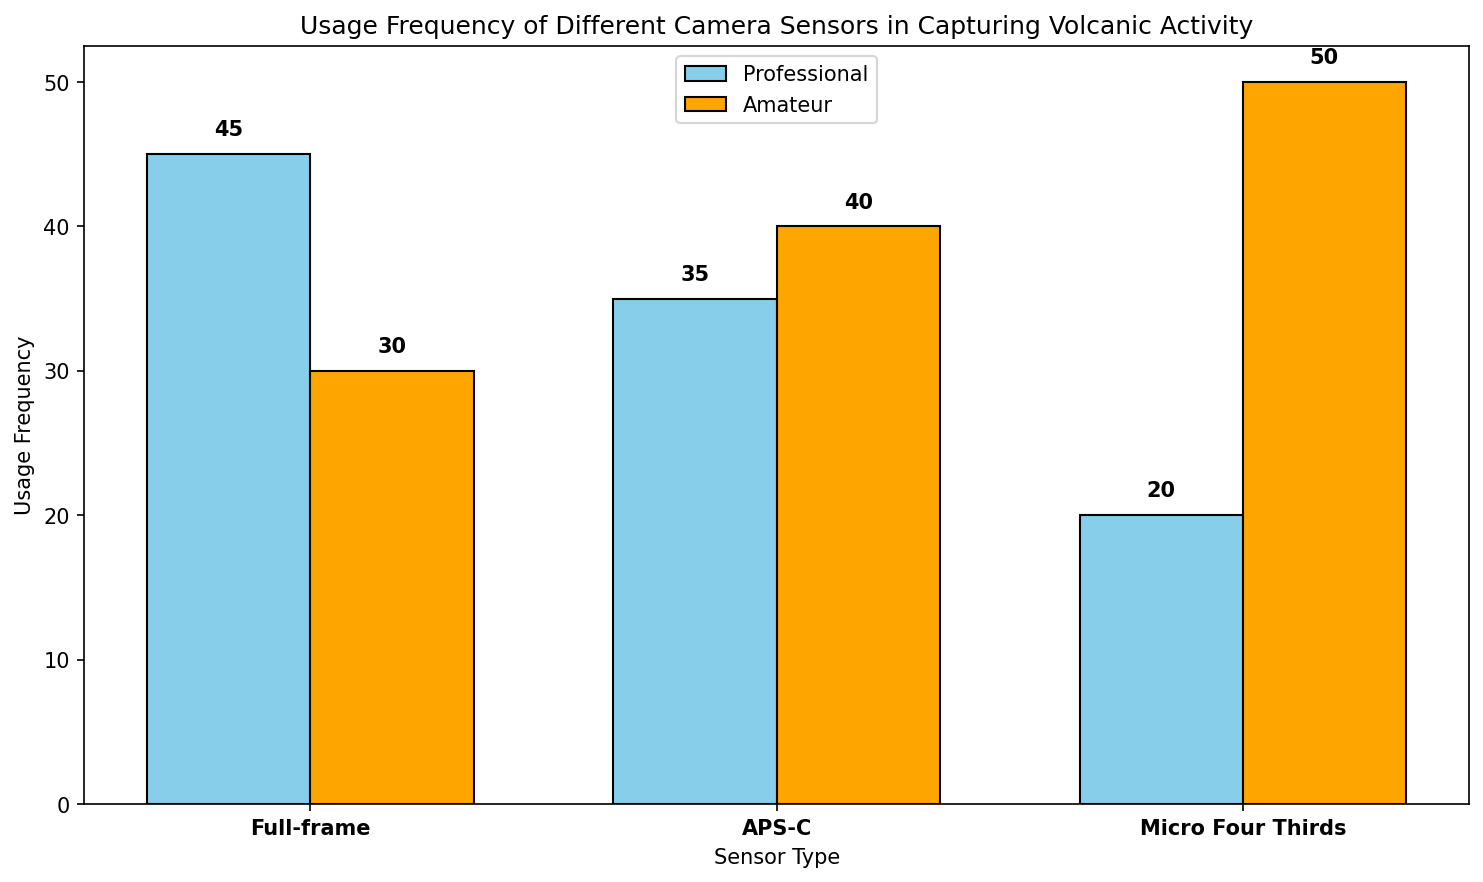Which sensor type do professional photographers use most frequently when capturing volcanic activity? Professional photographers use full-frame sensors most frequently. We can see this as the bar for full-frame sensor usage by professionals is the tallest compared to other sensors in its category, reaching 45 units of frequency.
Answer: Full-frame Which sensor type is more popular among amateur photographers, APS-C or Micro Four Thirds? To determine popularity, compare the height of the bars for amateur photographers under APS-C and Micro Four Thirds. The bar for Micro Four Thirds is taller than that of APS-C for amateur photographers, with a usage frequency of 50 versus 40. Therefore, Micro Four Thirds is more popular among amateurs.
Answer: Micro Four Thirds What is the total usage frequency for APS-C sensors by both professional and amateur photographers? To find the total, add the usage frequencies of APS-C sensors by professionals and amateurs. The usage frequency is 35 for professionals and 40 for amateurs, resulting in a sum of 35 + 40 = 75.
Answer: 75 Is the usage frequency of full-frame sensors by professional photographers greater than the sum of the usage frequencies of all other sensors by professional photographers? First, check the usage frequency of full-frame sensors by professionals, which is 45. Then, sum the usage frequencies of APS-C (35) and Micro Four Thirds (20) by professionals, which totals 35 + 20 = 55. Since 45 is not greater than 55, the full-frame usage is not greater than the sum of the others.
Answer: No Which user type, professional or amateur, uses Micro Four Thirds sensors more frequently for volcanic photography? Compare the heights of the bars for professional and amateur photographers using Micro Four Thirds sensors. The bar for amateurs reaches a usage frequency of 50, which is higher than 20 for professionals. Therefore, amateurs use Micro Four Thirds sensors more frequently.
Answer: Amateur What is the difference in usage frequency of Micro Four Thirds sensors between amateur and professional photographers? Subtract the usage frequency of professional photographers from that of amateur photographers for Micro Four Thirds sensors. The values are 50 for amateurs and 20 for professionals, resulting in a difference of 50 - 20 = 30.
Answer: 30 What is the average usage frequency of full-frame sensors when considering both professional and amateur photographers? To calculate the average, add the usage frequencies of full-frame sensors by professionals (45) and amateurs (30), then divide by 2. The sum is 45 + 30 = 75, and the average is 75 ÷ 2 = 37.5.
Answer: 37.5 